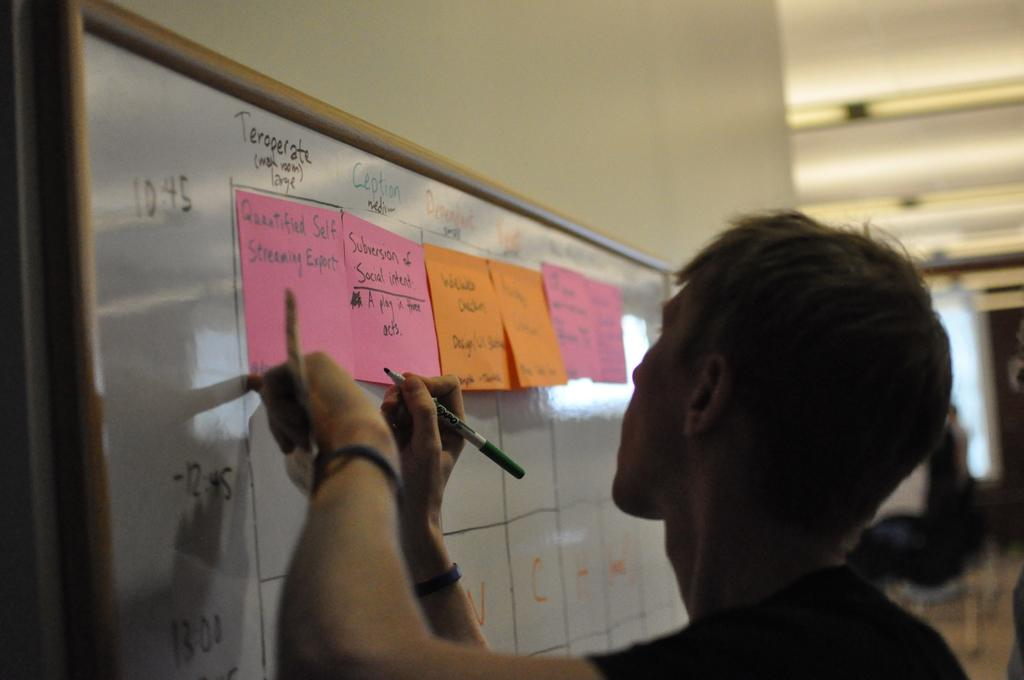Provide a one-sentence caption for the provided image. a person writes on a white board with post its reading Quatified Self Streaming Expert. 